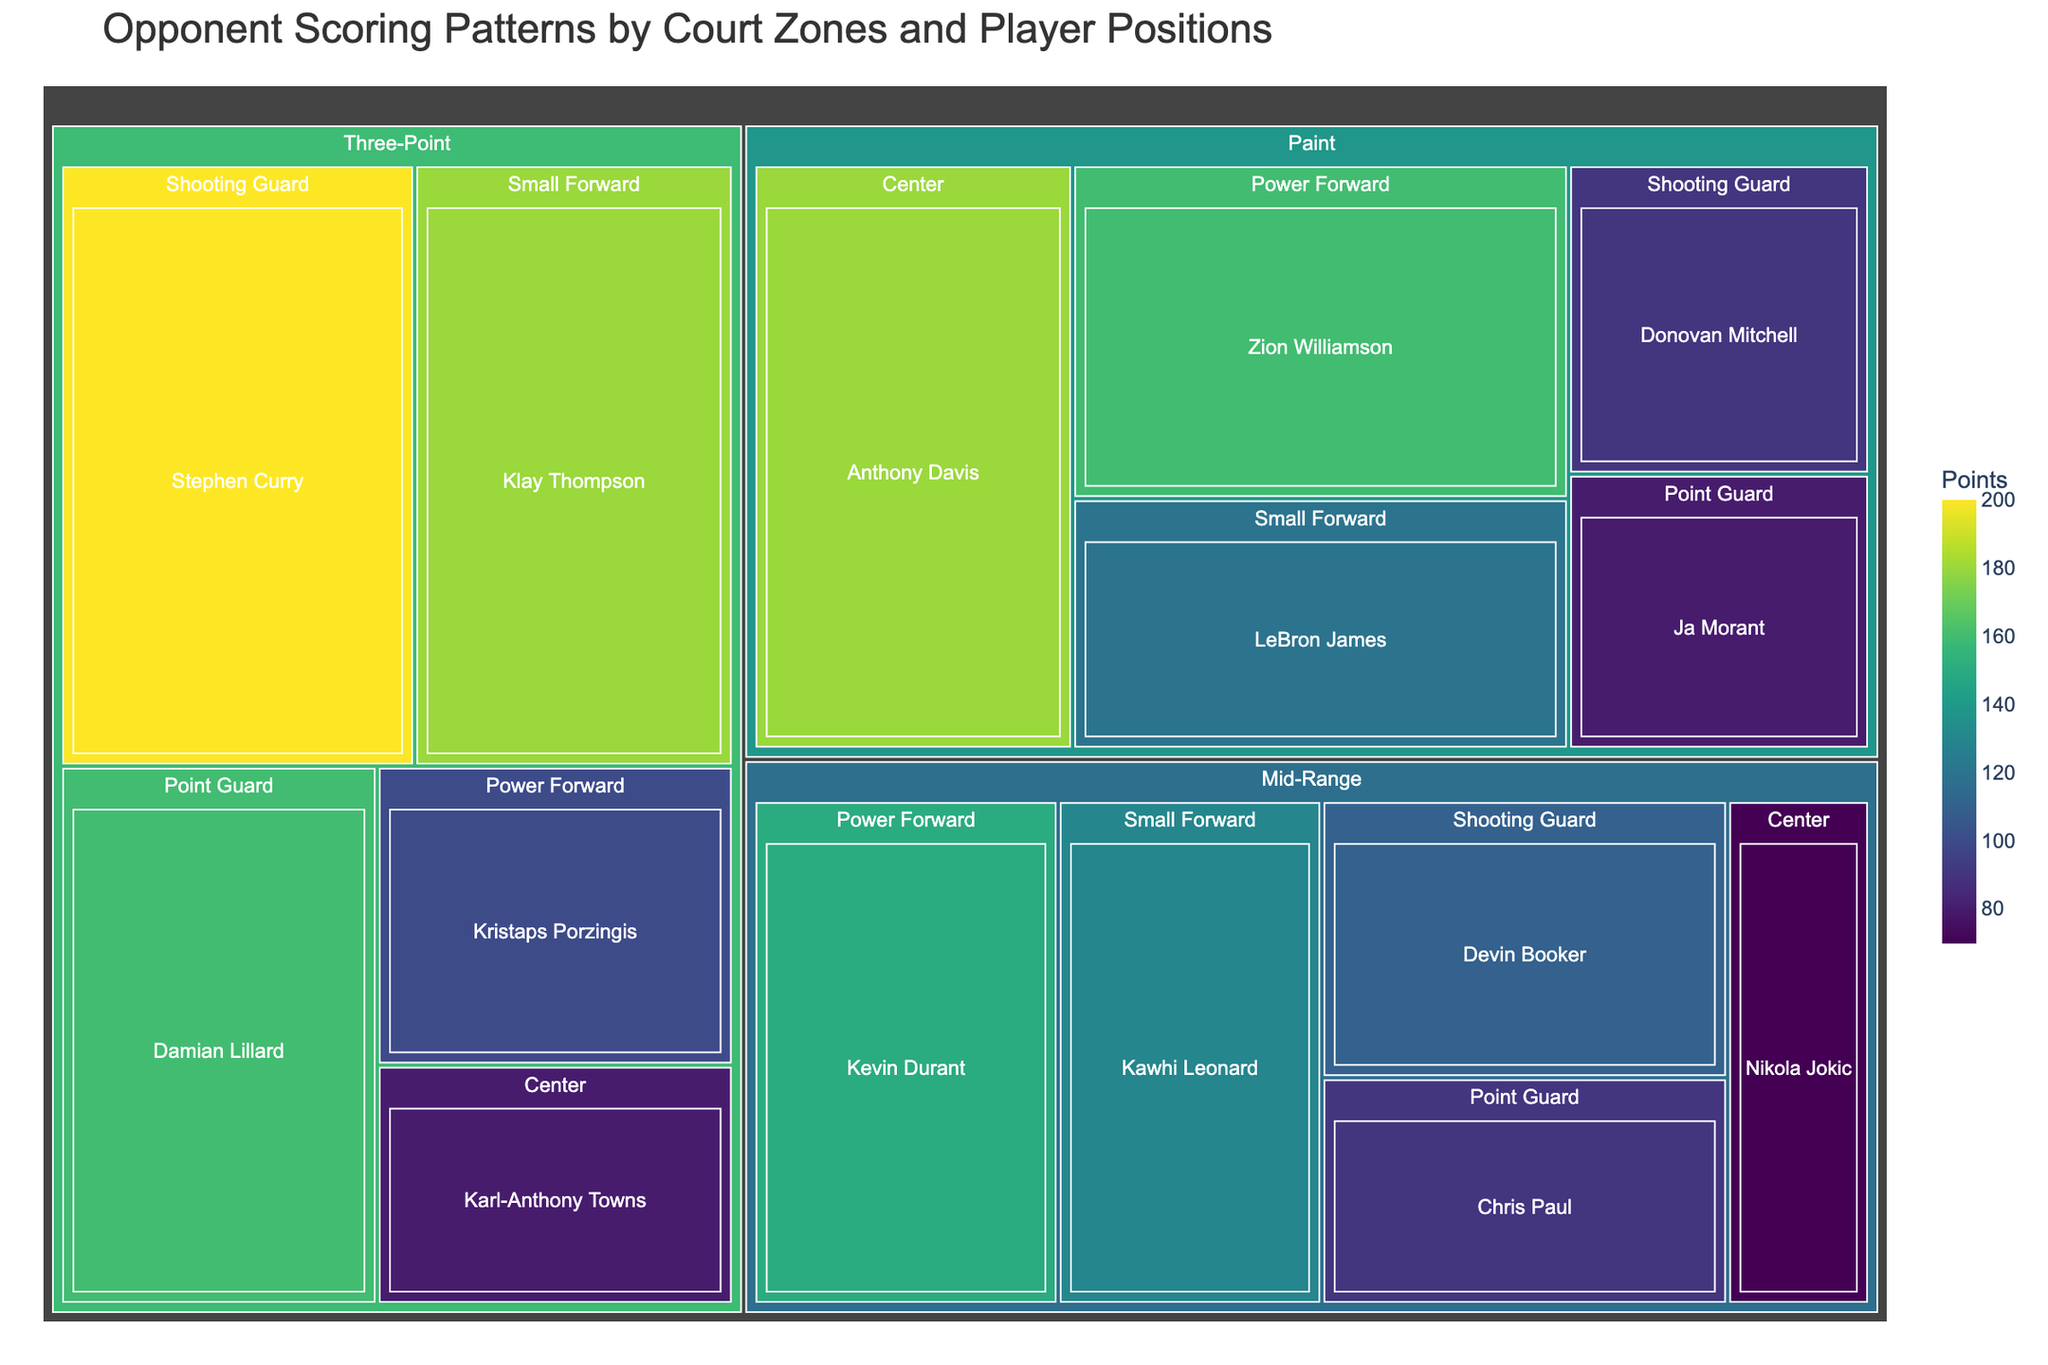What is the title of the treemap? The title is usually found at the top of the treemap, and it provides a brief description of what the treemap represents.
Answer: Opponent Scoring Patterns by Court Zones and Player Positions Which player scored the most points in the Paint zone? Look for the zone labeled "Paint" and then find the player with the largest segment, which also has the highest numerical value.
Answer: Anthony Davis How many points did Stephen Curry score from the Three-Point zone? Locate the Three-Point zone on the treemap and find Stephen Curry's segment. The points will be displayed within or next to the segment.
Answer: 200 Which zone had the highest aggregate points? Sum the points for all players within each zone. Compare the totals for Paint, Mid-Range, and Three-Point zones to determine the highest aggregate.
Answer: Three-Point Who scored more points, Zion Williamson or LeBron James in the Paint zone? Within the Paint zone, identify the segments for Zion Williamson and LeBron James. Compare their points directly.
Answer: Zion Williamson What's the total points scored by Power Forwards across all zones? Find all segments labeled with the position "Power Forward" across each zone (Paint, Mid-Range, Three-Point), and sum their points.
Answer: 410 Who scored the fewest points among all players in the treemap? Identify the player with the smallest segment across all zones.
Answer: Karl-Anthony Towns Between the Paint zone and the Mid-Range zone, which has more variance in points scored by different players? Assess the range of points within each zone. Paint has 100 points variance (80-180) while Mid-Range has 80 points variance (70-150).
Answer: Paint What is the average points scored by Centers across all zones? Sum the points for all segments labeled as "Center," then divide by the number of Centers. (180+70+80)/3 = 110
Answer: 110 How many zones did Klay Thompson score in? Find all segments labeled with the player "Klay Thompson" and count the number of unique zones.
Answer: 1 